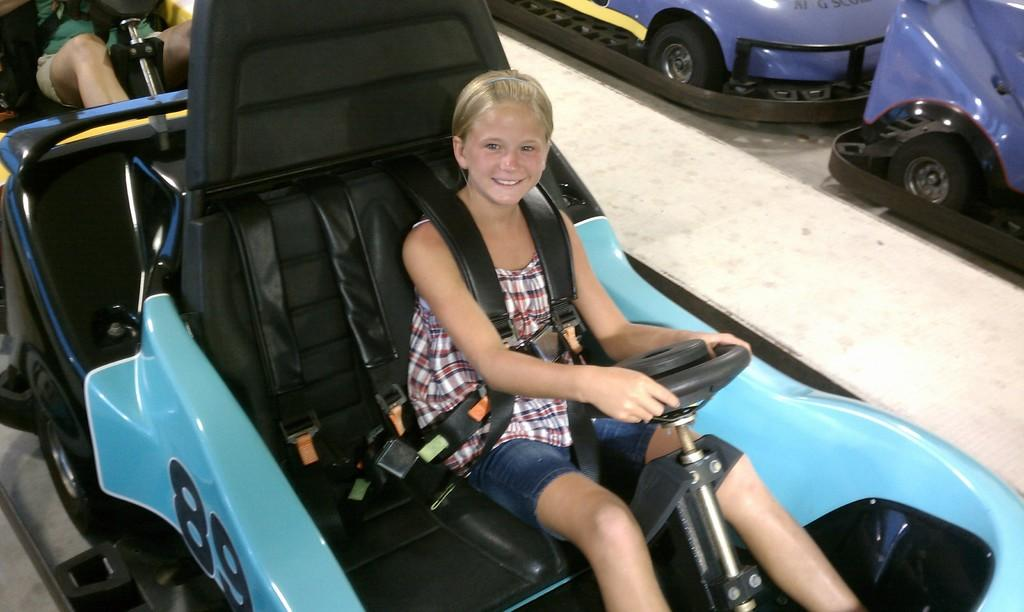What type of activity is depicted in the image? There are rides in the image, suggesting an amusement park or carnival setting. Can you describe the people in the image? Two persons are sitting on the rides. How does one of the persons appear to be feeling? There is a smile on the face of one of the persons, indicating happiness or enjoyment. What else can be seen in the image besides the rides and people? There is text visible in the image. What type of card game is being played in the image? There is no card game present in the image; it features rides and people at an amusement park or carnival. Is there a bathtub visible in the image? No, there is no bathtub present in the image. 